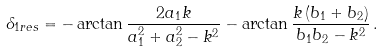Convert formula to latex. <formula><loc_0><loc_0><loc_500><loc_500>\delta _ { 1 r e s } = - \arctan \frac { 2 a _ { 1 } k } { a _ { 1 } ^ { 2 } + a _ { 2 } ^ { 2 } - k ^ { 2 } } - \arctan \frac { k \left ( b _ { 1 } + b _ { 2 } \right ) } { b _ { 1 } b _ { 2 } - k ^ { 2 } } \, .</formula> 